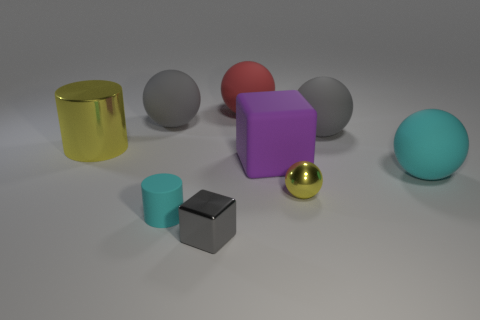What can you infer about the texture and material of these objects? The objects display a variety of textures and materials. The golden cylinder and the small golden sphere have glossy finishes suggesting they might be metallic. The gray, pink, and turquoise spheres, along with the lavender cube and small cyan cylinder, all have a dull, matte finish, possibly made of plastic or rubber. The chrome cube stands out with a very reflective surface, indicating a polished metal material. 